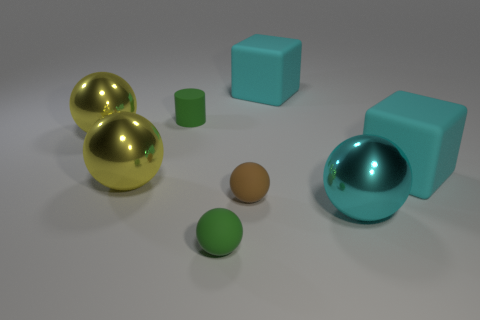Subtract all big cyan shiny spheres. How many spheres are left? 4 Subtract all brown balls. How many balls are left? 4 Subtract all cylinders. How many objects are left? 7 Subtract 1 cylinders. How many cylinders are left? 0 Add 1 green spheres. How many objects exist? 9 Subtract all blue cylinders. How many purple spheres are left? 0 Subtract all big cyan spheres. Subtract all cyan cubes. How many objects are left? 5 Add 6 green matte things. How many green matte things are left? 8 Add 5 tiny red rubber cylinders. How many tiny red rubber cylinders exist? 5 Subtract 1 cyan spheres. How many objects are left? 7 